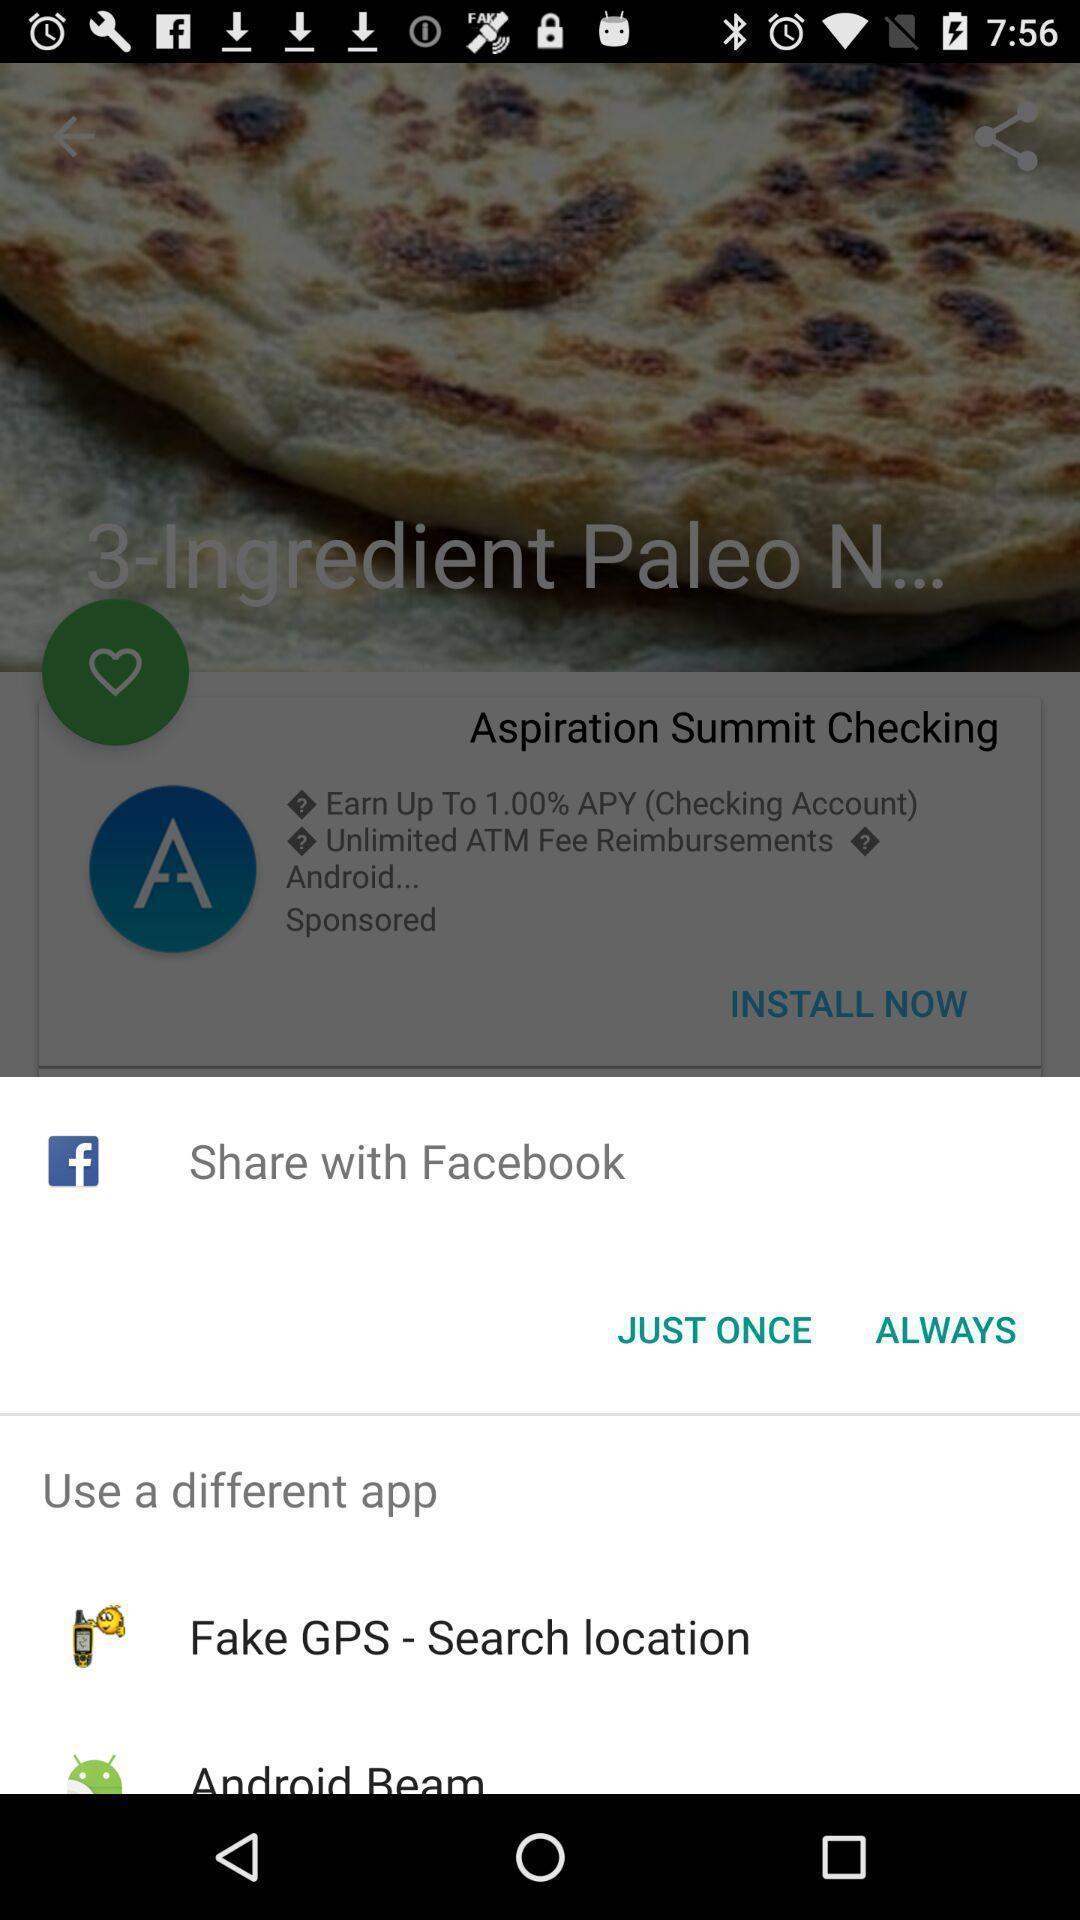What is the overall content of this screenshot? Popup showing to share with application. 